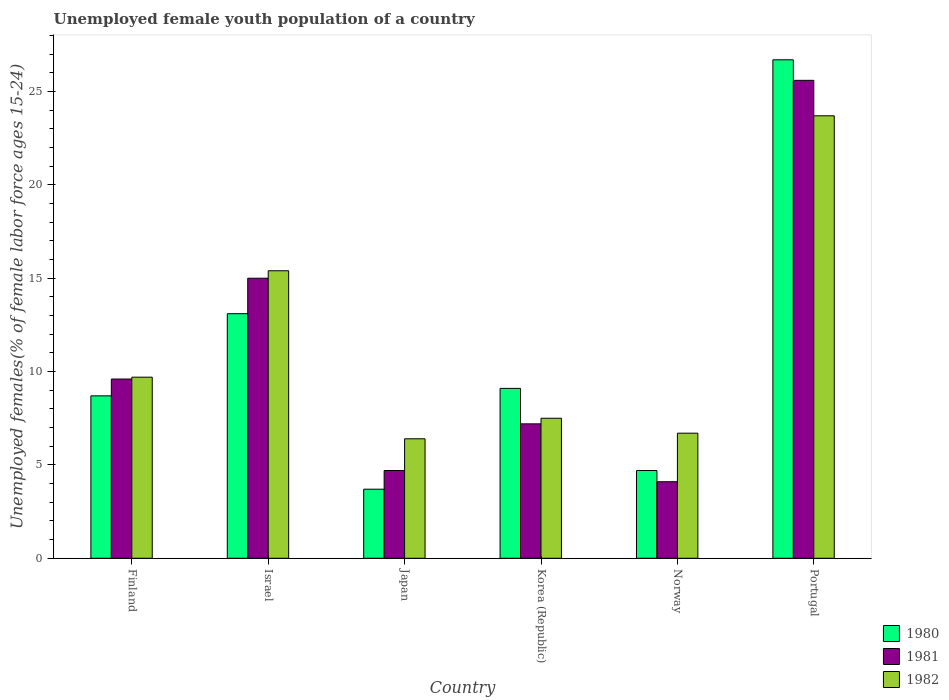How many different coloured bars are there?
Provide a short and direct response. 3. How many groups of bars are there?
Keep it short and to the point. 6. Are the number of bars on each tick of the X-axis equal?
Ensure brevity in your answer.  Yes. What is the label of the 5th group of bars from the left?
Provide a succinct answer. Norway. What is the percentage of unemployed female youth population in 1982 in Israel?
Your answer should be very brief. 15.4. Across all countries, what is the maximum percentage of unemployed female youth population in 1981?
Your answer should be very brief. 25.6. Across all countries, what is the minimum percentage of unemployed female youth population in 1981?
Give a very brief answer. 4.1. In which country was the percentage of unemployed female youth population in 1982 maximum?
Give a very brief answer. Portugal. In which country was the percentage of unemployed female youth population in 1981 minimum?
Give a very brief answer. Norway. What is the total percentage of unemployed female youth population in 1980 in the graph?
Offer a very short reply. 66. What is the difference between the percentage of unemployed female youth population in 1982 in Israel and that in Korea (Republic)?
Make the answer very short. 7.9. What is the difference between the percentage of unemployed female youth population in 1982 in Israel and the percentage of unemployed female youth population in 1981 in Korea (Republic)?
Ensure brevity in your answer.  8.2. What is the average percentage of unemployed female youth population in 1980 per country?
Give a very brief answer. 11. What is the difference between the percentage of unemployed female youth population of/in 1980 and percentage of unemployed female youth population of/in 1981 in Portugal?
Make the answer very short. 1.1. What is the ratio of the percentage of unemployed female youth population in 1982 in Norway to that in Portugal?
Ensure brevity in your answer.  0.28. Is the percentage of unemployed female youth population in 1981 in Finland less than that in Portugal?
Your answer should be compact. Yes. Is the difference between the percentage of unemployed female youth population in 1980 in Korea (Republic) and Portugal greater than the difference between the percentage of unemployed female youth population in 1981 in Korea (Republic) and Portugal?
Your response must be concise. Yes. What is the difference between the highest and the second highest percentage of unemployed female youth population in 1982?
Your answer should be very brief. -5.7. What is the difference between the highest and the lowest percentage of unemployed female youth population in 1981?
Make the answer very short. 21.5. Is the sum of the percentage of unemployed female youth population in 1981 in Finland and Japan greater than the maximum percentage of unemployed female youth population in 1980 across all countries?
Provide a succinct answer. No. What does the 1st bar from the left in Finland represents?
Offer a terse response. 1980. Is it the case that in every country, the sum of the percentage of unemployed female youth population in 1980 and percentage of unemployed female youth population in 1981 is greater than the percentage of unemployed female youth population in 1982?
Ensure brevity in your answer.  Yes. How many countries are there in the graph?
Offer a very short reply. 6. Are the values on the major ticks of Y-axis written in scientific E-notation?
Provide a short and direct response. No. Does the graph contain any zero values?
Provide a succinct answer. No. How many legend labels are there?
Keep it short and to the point. 3. What is the title of the graph?
Offer a very short reply. Unemployed female youth population of a country. Does "1969" appear as one of the legend labels in the graph?
Provide a succinct answer. No. What is the label or title of the Y-axis?
Provide a short and direct response. Unemployed females(% of female labor force ages 15-24). What is the Unemployed females(% of female labor force ages 15-24) in 1980 in Finland?
Ensure brevity in your answer.  8.7. What is the Unemployed females(% of female labor force ages 15-24) in 1981 in Finland?
Your response must be concise. 9.6. What is the Unemployed females(% of female labor force ages 15-24) of 1982 in Finland?
Offer a very short reply. 9.7. What is the Unemployed females(% of female labor force ages 15-24) of 1980 in Israel?
Give a very brief answer. 13.1. What is the Unemployed females(% of female labor force ages 15-24) of 1981 in Israel?
Make the answer very short. 15. What is the Unemployed females(% of female labor force ages 15-24) in 1982 in Israel?
Give a very brief answer. 15.4. What is the Unemployed females(% of female labor force ages 15-24) of 1980 in Japan?
Your answer should be very brief. 3.7. What is the Unemployed females(% of female labor force ages 15-24) in 1981 in Japan?
Your answer should be compact. 4.7. What is the Unemployed females(% of female labor force ages 15-24) in 1982 in Japan?
Give a very brief answer. 6.4. What is the Unemployed females(% of female labor force ages 15-24) of 1980 in Korea (Republic)?
Offer a very short reply. 9.1. What is the Unemployed females(% of female labor force ages 15-24) in 1981 in Korea (Republic)?
Your response must be concise. 7.2. What is the Unemployed females(% of female labor force ages 15-24) in 1982 in Korea (Republic)?
Provide a succinct answer. 7.5. What is the Unemployed females(% of female labor force ages 15-24) of 1980 in Norway?
Give a very brief answer. 4.7. What is the Unemployed females(% of female labor force ages 15-24) in 1981 in Norway?
Offer a terse response. 4.1. What is the Unemployed females(% of female labor force ages 15-24) of 1982 in Norway?
Provide a succinct answer. 6.7. What is the Unemployed females(% of female labor force ages 15-24) of 1980 in Portugal?
Offer a terse response. 26.7. What is the Unemployed females(% of female labor force ages 15-24) of 1981 in Portugal?
Your answer should be very brief. 25.6. What is the Unemployed females(% of female labor force ages 15-24) of 1982 in Portugal?
Give a very brief answer. 23.7. Across all countries, what is the maximum Unemployed females(% of female labor force ages 15-24) in 1980?
Your answer should be compact. 26.7. Across all countries, what is the maximum Unemployed females(% of female labor force ages 15-24) in 1981?
Your answer should be compact. 25.6. Across all countries, what is the maximum Unemployed females(% of female labor force ages 15-24) in 1982?
Make the answer very short. 23.7. Across all countries, what is the minimum Unemployed females(% of female labor force ages 15-24) of 1980?
Offer a very short reply. 3.7. Across all countries, what is the minimum Unemployed females(% of female labor force ages 15-24) of 1981?
Your answer should be compact. 4.1. Across all countries, what is the minimum Unemployed females(% of female labor force ages 15-24) in 1982?
Your answer should be compact. 6.4. What is the total Unemployed females(% of female labor force ages 15-24) of 1981 in the graph?
Your answer should be very brief. 66.2. What is the total Unemployed females(% of female labor force ages 15-24) of 1982 in the graph?
Your answer should be very brief. 69.4. What is the difference between the Unemployed females(% of female labor force ages 15-24) of 1981 in Finland and that in Israel?
Offer a very short reply. -5.4. What is the difference between the Unemployed females(% of female labor force ages 15-24) of 1980 in Finland and that in Japan?
Your answer should be compact. 5. What is the difference between the Unemployed females(% of female labor force ages 15-24) in 1980 in Finland and that in Portugal?
Your answer should be very brief. -18. What is the difference between the Unemployed females(% of female labor force ages 15-24) in 1981 in Finland and that in Portugal?
Keep it short and to the point. -16. What is the difference between the Unemployed females(% of female labor force ages 15-24) in 1980 in Israel and that in Japan?
Make the answer very short. 9.4. What is the difference between the Unemployed females(% of female labor force ages 15-24) of 1981 in Israel and that in Japan?
Your response must be concise. 10.3. What is the difference between the Unemployed females(% of female labor force ages 15-24) in 1981 in Israel and that in Korea (Republic)?
Your response must be concise. 7.8. What is the difference between the Unemployed females(% of female labor force ages 15-24) in 1982 in Israel and that in Korea (Republic)?
Your answer should be compact. 7.9. What is the difference between the Unemployed females(% of female labor force ages 15-24) of 1980 in Israel and that in Norway?
Offer a very short reply. 8.4. What is the difference between the Unemployed females(% of female labor force ages 15-24) in 1982 in Israel and that in Norway?
Offer a very short reply. 8.7. What is the difference between the Unemployed females(% of female labor force ages 15-24) of 1980 in Israel and that in Portugal?
Your response must be concise. -13.6. What is the difference between the Unemployed females(% of female labor force ages 15-24) in 1981 in Israel and that in Portugal?
Give a very brief answer. -10.6. What is the difference between the Unemployed females(% of female labor force ages 15-24) of 1982 in Israel and that in Portugal?
Your response must be concise. -8.3. What is the difference between the Unemployed females(% of female labor force ages 15-24) of 1980 in Japan and that in Korea (Republic)?
Your response must be concise. -5.4. What is the difference between the Unemployed females(% of female labor force ages 15-24) of 1981 in Japan and that in Korea (Republic)?
Keep it short and to the point. -2.5. What is the difference between the Unemployed females(% of female labor force ages 15-24) of 1980 in Japan and that in Norway?
Provide a short and direct response. -1. What is the difference between the Unemployed females(% of female labor force ages 15-24) in 1982 in Japan and that in Norway?
Offer a very short reply. -0.3. What is the difference between the Unemployed females(% of female labor force ages 15-24) of 1981 in Japan and that in Portugal?
Provide a succinct answer. -20.9. What is the difference between the Unemployed females(% of female labor force ages 15-24) of 1982 in Japan and that in Portugal?
Keep it short and to the point. -17.3. What is the difference between the Unemployed females(% of female labor force ages 15-24) of 1980 in Korea (Republic) and that in Norway?
Your response must be concise. 4.4. What is the difference between the Unemployed females(% of female labor force ages 15-24) of 1982 in Korea (Republic) and that in Norway?
Your answer should be very brief. 0.8. What is the difference between the Unemployed females(% of female labor force ages 15-24) in 1980 in Korea (Republic) and that in Portugal?
Make the answer very short. -17.6. What is the difference between the Unemployed females(% of female labor force ages 15-24) in 1981 in Korea (Republic) and that in Portugal?
Offer a terse response. -18.4. What is the difference between the Unemployed females(% of female labor force ages 15-24) in 1982 in Korea (Republic) and that in Portugal?
Your answer should be compact. -16.2. What is the difference between the Unemployed females(% of female labor force ages 15-24) in 1980 in Norway and that in Portugal?
Provide a succinct answer. -22. What is the difference between the Unemployed females(% of female labor force ages 15-24) in 1981 in Norway and that in Portugal?
Keep it short and to the point. -21.5. What is the difference between the Unemployed females(% of female labor force ages 15-24) of 1980 in Finland and the Unemployed females(% of female labor force ages 15-24) of 1981 in Israel?
Your response must be concise. -6.3. What is the difference between the Unemployed females(% of female labor force ages 15-24) of 1980 in Finland and the Unemployed females(% of female labor force ages 15-24) of 1982 in Japan?
Offer a terse response. 2.3. What is the difference between the Unemployed females(% of female labor force ages 15-24) of 1981 in Finland and the Unemployed females(% of female labor force ages 15-24) of 1982 in Japan?
Offer a terse response. 3.2. What is the difference between the Unemployed females(% of female labor force ages 15-24) of 1980 in Finland and the Unemployed females(% of female labor force ages 15-24) of 1982 in Korea (Republic)?
Offer a terse response. 1.2. What is the difference between the Unemployed females(% of female labor force ages 15-24) of 1980 in Finland and the Unemployed females(% of female labor force ages 15-24) of 1982 in Norway?
Your answer should be very brief. 2. What is the difference between the Unemployed females(% of female labor force ages 15-24) of 1981 in Finland and the Unemployed females(% of female labor force ages 15-24) of 1982 in Norway?
Make the answer very short. 2.9. What is the difference between the Unemployed females(% of female labor force ages 15-24) of 1980 in Finland and the Unemployed females(% of female labor force ages 15-24) of 1981 in Portugal?
Ensure brevity in your answer.  -16.9. What is the difference between the Unemployed females(% of female labor force ages 15-24) of 1981 in Finland and the Unemployed females(% of female labor force ages 15-24) of 1982 in Portugal?
Offer a terse response. -14.1. What is the difference between the Unemployed females(% of female labor force ages 15-24) in 1980 in Israel and the Unemployed females(% of female labor force ages 15-24) in 1982 in Japan?
Give a very brief answer. 6.7. What is the difference between the Unemployed females(% of female labor force ages 15-24) of 1980 in Israel and the Unemployed females(% of female labor force ages 15-24) of 1981 in Korea (Republic)?
Your response must be concise. 5.9. What is the difference between the Unemployed females(% of female labor force ages 15-24) in 1980 in Israel and the Unemployed females(% of female labor force ages 15-24) in 1982 in Korea (Republic)?
Keep it short and to the point. 5.6. What is the difference between the Unemployed females(% of female labor force ages 15-24) in 1980 in Israel and the Unemployed females(% of female labor force ages 15-24) in 1981 in Norway?
Ensure brevity in your answer.  9. What is the difference between the Unemployed females(% of female labor force ages 15-24) in 1981 in Israel and the Unemployed females(% of female labor force ages 15-24) in 1982 in Norway?
Provide a short and direct response. 8.3. What is the difference between the Unemployed females(% of female labor force ages 15-24) of 1980 in Israel and the Unemployed females(% of female labor force ages 15-24) of 1981 in Portugal?
Offer a terse response. -12.5. What is the difference between the Unemployed females(% of female labor force ages 15-24) of 1980 in Israel and the Unemployed females(% of female labor force ages 15-24) of 1982 in Portugal?
Your response must be concise. -10.6. What is the difference between the Unemployed females(% of female labor force ages 15-24) in 1980 in Japan and the Unemployed females(% of female labor force ages 15-24) in 1981 in Korea (Republic)?
Keep it short and to the point. -3.5. What is the difference between the Unemployed females(% of female labor force ages 15-24) in 1980 in Japan and the Unemployed females(% of female labor force ages 15-24) in 1981 in Norway?
Keep it short and to the point. -0.4. What is the difference between the Unemployed females(% of female labor force ages 15-24) in 1980 in Japan and the Unemployed females(% of female labor force ages 15-24) in 1981 in Portugal?
Make the answer very short. -21.9. What is the difference between the Unemployed females(% of female labor force ages 15-24) of 1981 in Japan and the Unemployed females(% of female labor force ages 15-24) of 1982 in Portugal?
Provide a short and direct response. -19. What is the difference between the Unemployed females(% of female labor force ages 15-24) in 1980 in Korea (Republic) and the Unemployed females(% of female labor force ages 15-24) in 1982 in Norway?
Offer a very short reply. 2.4. What is the difference between the Unemployed females(% of female labor force ages 15-24) of 1981 in Korea (Republic) and the Unemployed females(% of female labor force ages 15-24) of 1982 in Norway?
Your answer should be very brief. 0.5. What is the difference between the Unemployed females(% of female labor force ages 15-24) in 1980 in Korea (Republic) and the Unemployed females(% of female labor force ages 15-24) in 1981 in Portugal?
Your answer should be very brief. -16.5. What is the difference between the Unemployed females(% of female labor force ages 15-24) of 1980 in Korea (Republic) and the Unemployed females(% of female labor force ages 15-24) of 1982 in Portugal?
Keep it short and to the point. -14.6. What is the difference between the Unemployed females(% of female labor force ages 15-24) in 1981 in Korea (Republic) and the Unemployed females(% of female labor force ages 15-24) in 1982 in Portugal?
Ensure brevity in your answer.  -16.5. What is the difference between the Unemployed females(% of female labor force ages 15-24) of 1980 in Norway and the Unemployed females(% of female labor force ages 15-24) of 1981 in Portugal?
Ensure brevity in your answer.  -20.9. What is the difference between the Unemployed females(% of female labor force ages 15-24) in 1980 in Norway and the Unemployed females(% of female labor force ages 15-24) in 1982 in Portugal?
Offer a very short reply. -19. What is the difference between the Unemployed females(% of female labor force ages 15-24) in 1981 in Norway and the Unemployed females(% of female labor force ages 15-24) in 1982 in Portugal?
Provide a succinct answer. -19.6. What is the average Unemployed females(% of female labor force ages 15-24) in 1981 per country?
Keep it short and to the point. 11.03. What is the average Unemployed females(% of female labor force ages 15-24) of 1982 per country?
Make the answer very short. 11.57. What is the difference between the Unemployed females(% of female labor force ages 15-24) of 1980 and Unemployed females(% of female labor force ages 15-24) of 1982 in Israel?
Offer a very short reply. -2.3. What is the difference between the Unemployed females(% of female labor force ages 15-24) in 1980 and Unemployed females(% of female labor force ages 15-24) in 1981 in Japan?
Make the answer very short. -1. What is the difference between the Unemployed females(% of female labor force ages 15-24) of 1980 and Unemployed females(% of female labor force ages 15-24) of 1982 in Japan?
Your answer should be very brief. -2.7. What is the difference between the Unemployed females(% of female labor force ages 15-24) in 1981 and Unemployed females(% of female labor force ages 15-24) in 1982 in Japan?
Your response must be concise. -1.7. What is the difference between the Unemployed females(% of female labor force ages 15-24) of 1981 and Unemployed females(% of female labor force ages 15-24) of 1982 in Korea (Republic)?
Ensure brevity in your answer.  -0.3. What is the difference between the Unemployed females(% of female labor force ages 15-24) of 1980 and Unemployed females(% of female labor force ages 15-24) of 1981 in Norway?
Ensure brevity in your answer.  0.6. What is the difference between the Unemployed females(% of female labor force ages 15-24) of 1980 and Unemployed females(% of female labor force ages 15-24) of 1982 in Norway?
Offer a terse response. -2. What is the difference between the Unemployed females(% of female labor force ages 15-24) of 1981 and Unemployed females(% of female labor force ages 15-24) of 1982 in Norway?
Provide a short and direct response. -2.6. What is the ratio of the Unemployed females(% of female labor force ages 15-24) of 1980 in Finland to that in Israel?
Make the answer very short. 0.66. What is the ratio of the Unemployed females(% of female labor force ages 15-24) in 1981 in Finland to that in Israel?
Provide a succinct answer. 0.64. What is the ratio of the Unemployed females(% of female labor force ages 15-24) in 1982 in Finland to that in Israel?
Your answer should be very brief. 0.63. What is the ratio of the Unemployed females(% of female labor force ages 15-24) in 1980 in Finland to that in Japan?
Your answer should be very brief. 2.35. What is the ratio of the Unemployed females(% of female labor force ages 15-24) in 1981 in Finland to that in Japan?
Keep it short and to the point. 2.04. What is the ratio of the Unemployed females(% of female labor force ages 15-24) of 1982 in Finland to that in Japan?
Make the answer very short. 1.52. What is the ratio of the Unemployed females(% of female labor force ages 15-24) in 1980 in Finland to that in Korea (Republic)?
Provide a succinct answer. 0.96. What is the ratio of the Unemployed females(% of female labor force ages 15-24) in 1981 in Finland to that in Korea (Republic)?
Give a very brief answer. 1.33. What is the ratio of the Unemployed females(% of female labor force ages 15-24) of 1982 in Finland to that in Korea (Republic)?
Offer a very short reply. 1.29. What is the ratio of the Unemployed females(% of female labor force ages 15-24) of 1980 in Finland to that in Norway?
Make the answer very short. 1.85. What is the ratio of the Unemployed females(% of female labor force ages 15-24) in 1981 in Finland to that in Norway?
Ensure brevity in your answer.  2.34. What is the ratio of the Unemployed females(% of female labor force ages 15-24) of 1982 in Finland to that in Norway?
Ensure brevity in your answer.  1.45. What is the ratio of the Unemployed females(% of female labor force ages 15-24) of 1980 in Finland to that in Portugal?
Provide a succinct answer. 0.33. What is the ratio of the Unemployed females(% of female labor force ages 15-24) in 1981 in Finland to that in Portugal?
Provide a short and direct response. 0.38. What is the ratio of the Unemployed females(% of female labor force ages 15-24) in 1982 in Finland to that in Portugal?
Ensure brevity in your answer.  0.41. What is the ratio of the Unemployed females(% of female labor force ages 15-24) in 1980 in Israel to that in Japan?
Keep it short and to the point. 3.54. What is the ratio of the Unemployed females(% of female labor force ages 15-24) in 1981 in Israel to that in Japan?
Ensure brevity in your answer.  3.19. What is the ratio of the Unemployed females(% of female labor force ages 15-24) of 1982 in Israel to that in Japan?
Offer a very short reply. 2.41. What is the ratio of the Unemployed females(% of female labor force ages 15-24) in 1980 in Israel to that in Korea (Republic)?
Provide a short and direct response. 1.44. What is the ratio of the Unemployed females(% of female labor force ages 15-24) in 1981 in Israel to that in Korea (Republic)?
Your answer should be compact. 2.08. What is the ratio of the Unemployed females(% of female labor force ages 15-24) of 1982 in Israel to that in Korea (Republic)?
Offer a very short reply. 2.05. What is the ratio of the Unemployed females(% of female labor force ages 15-24) in 1980 in Israel to that in Norway?
Provide a short and direct response. 2.79. What is the ratio of the Unemployed females(% of female labor force ages 15-24) of 1981 in Israel to that in Norway?
Offer a terse response. 3.66. What is the ratio of the Unemployed females(% of female labor force ages 15-24) of 1982 in Israel to that in Norway?
Provide a succinct answer. 2.3. What is the ratio of the Unemployed females(% of female labor force ages 15-24) of 1980 in Israel to that in Portugal?
Your response must be concise. 0.49. What is the ratio of the Unemployed females(% of female labor force ages 15-24) of 1981 in Israel to that in Portugal?
Offer a very short reply. 0.59. What is the ratio of the Unemployed females(% of female labor force ages 15-24) in 1982 in Israel to that in Portugal?
Your answer should be very brief. 0.65. What is the ratio of the Unemployed females(% of female labor force ages 15-24) in 1980 in Japan to that in Korea (Republic)?
Make the answer very short. 0.41. What is the ratio of the Unemployed females(% of female labor force ages 15-24) of 1981 in Japan to that in Korea (Republic)?
Give a very brief answer. 0.65. What is the ratio of the Unemployed females(% of female labor force ages 15-24) of 1982 in Japan to that in Korea (Republic)?
Provide a short and direct response. 0.85. What is the ratio of the Unemployed females(% of female labor force ages 15-24) of 1980 in Japan to that in Norway?
Keep it short and to the point. 0.79. What is the ratio of the Unemployed females(% of female labor force ages 15-24) of 1981 in Japan to that in Norway?
Your response must be concise. 1.15. What is the ratio of the Unemployed females(% of female labor force ages 15-24) of 1982 in Japan to that in Norway?
Provide a succinct answer. 0.96. What is the ratio of the Unemployed females(% of female labor force ages 15-24) in 1980 in Japan to that in Portugal?
Offer a terse response. 0.14. What is the ratio of the Unemployed females(% of female labor force ages 15-24) of 1981 in Japan to that in Portugal?
Offer a terse response. 0.18. What is the ratio of the Unemployed females(% of female labor force ages 15-24) in 1982 in Japan to that in Portugal?
Your answer should be very brief. 0.27. What is the ratio of the Unemployed females(% of female labor force ages 15-24) of 1980 in Korea (Republic) to that in Norway?
Make the answer very short. 1.94. What is the ratio of the Unemployed females(% of female labor force ages 15-24) in 1981 in Korea (Republic) to that in Norway?
Give a very brief answer. 1.76. What is the ratio of the Unemployed females(% of female labor force ages 15-24) of 1982 in Korea (Republic) to that in Norway?
Your answer should be very brief. 1.12. What is the ratio of the Unemployed females(% of female labor force ages 15-24) in 1980 in Korea (Republic) to that in Portugal?
Keep it short and to the point. 0.34. What is the ratio of the Unemployed females(% of female labor force ages 15-24) in 1981 in Korea (Republic) to that in Portugal?
Make the answer very short. 0.28. What is the ratio of the Unemployed females(% of female labor force ages 15-24) of 1982 in Korea (Republic) to that in Portugal?
Offer a terse response. 0.32. What is the ratio of the Unemployed females(% of female labor force ages 15-24) in 1980 in Norway to that in Portugal?
Your answer should be compact. 0.18. What is the ratio of the Unemployed females(% of female labor force ages 15-24) of 1981 in Norway to that in Portugal?
Provide a succinct answer. 0.16. What is the ratio of the Unemployed females(% of female labor force ages 15-24) in 1982 in Norway to that in Portugal?
Give a very brief answer. 0.28. What is the difference between the highest and the second highest Unemployed females(% of female labor force ages 15-24) of 1980?
Your response must be concise. 13.6. What is the difference between the highest and the lowest Unemployed females(% of female labor force ages 15-24) in 1980?
Offer a terse response. 23. What is the difference between the highest and the lowest Unemployed females(% of female labor force ages 15-24) of 1981?
Give a very brief answer. 21.5. What is the difference between the highest and the lowest Unemployed females(% of female labor force ages 15-24) in 1982?
Offer a terse response. 17.3. 